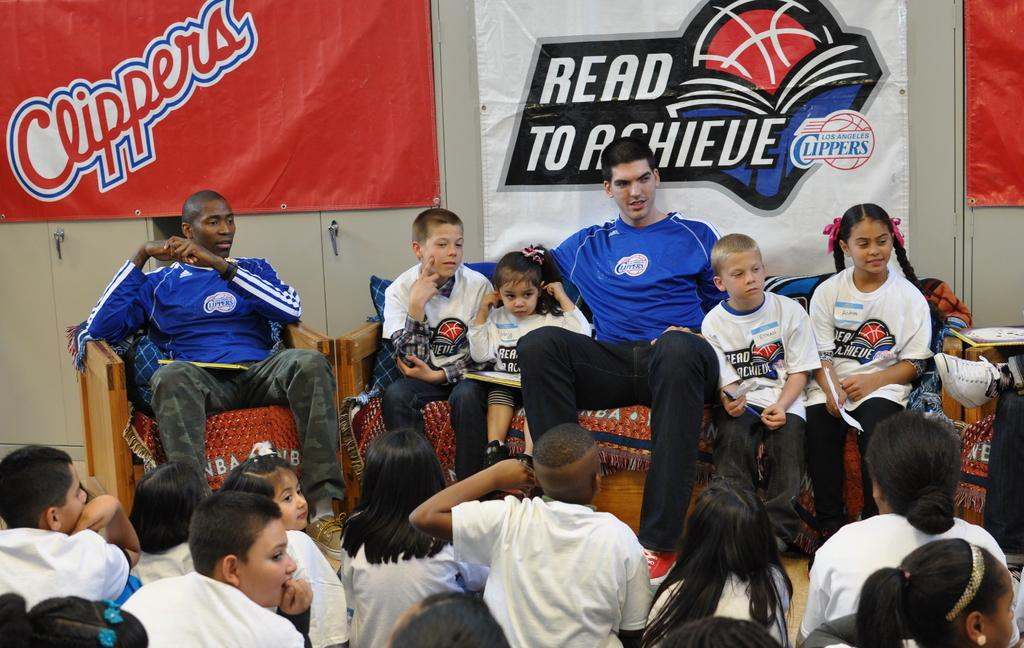<image>
Relay a brief, clear account of the picture shown. Two athletes wearing blue clippers shirts are sitting next to several children. 